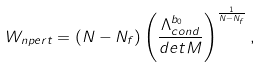<formula> <loc_0><loc_0><loc_500><loc_500>W _ { n p e r t } = ( N - N _ { f } ) \left ( \frac { \Lambda _ { c o n d } ^ { b _ { 0 } } } { d e t M } \right ) ^ { \frac { 1 } { N - N _ { f } } } ,</formula> 